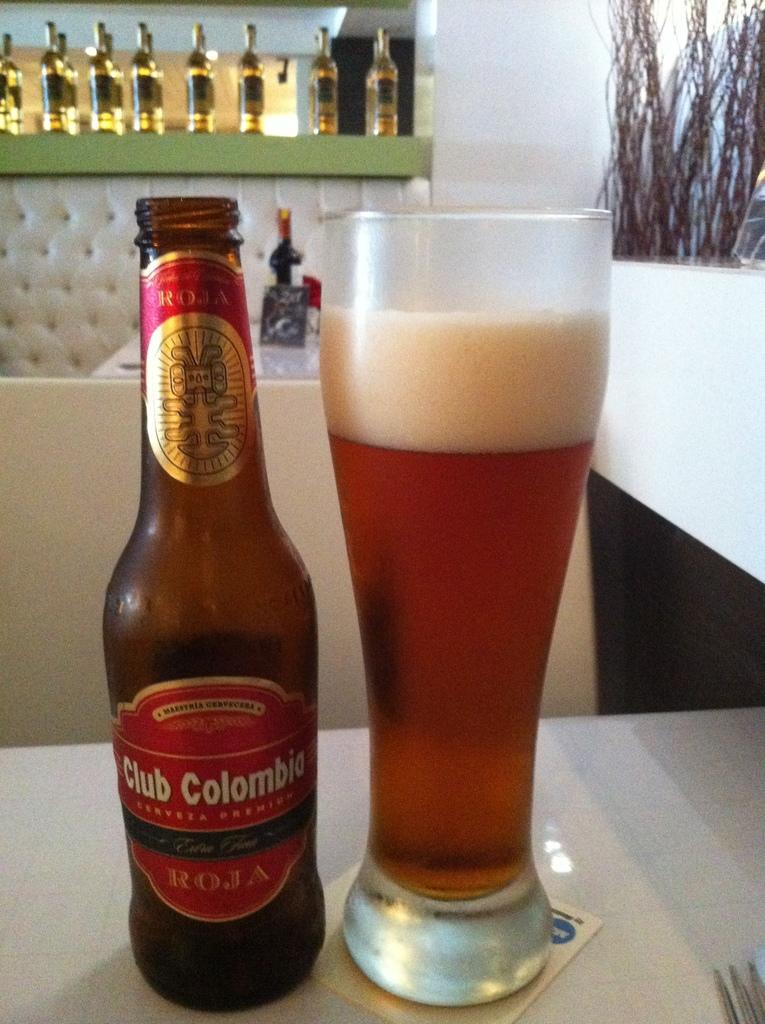<image>
Offer a succinct explanation of the picture presented. Bottle of Club Columbia sits next to a tall full glass on the table. 